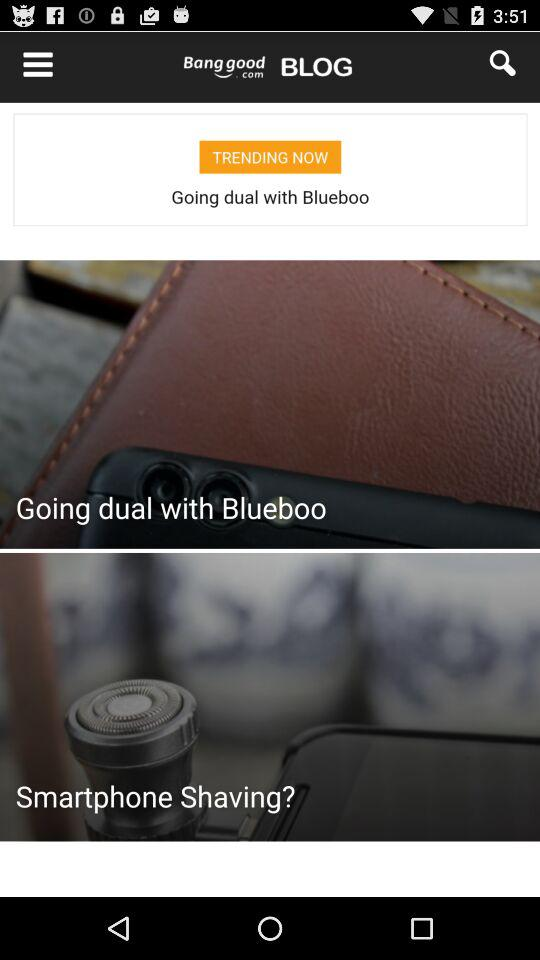What is the product name? The product name is "Vintage Women Stripe Printing Loose Harem Pants". 